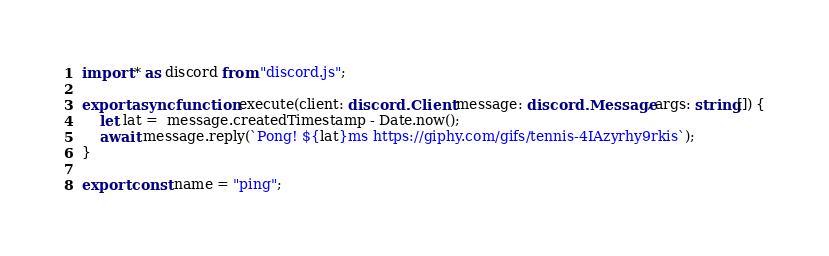Convert code to text. <code><loc_0><loc_0><loc_500><loc_500><_TypeScript_>import * as discord from "discord.js";

export async function execute(client: discord.Client, message: discord.Message, args: string[]) {
    let lat =  message.createdTimestamp - Date.now();
    await message.reply(`Pong! ${lat}ms https://giphy.com/gifs/tennis-4IAzyrhy9rkis`);
}

export const name = "ping";
</code> 